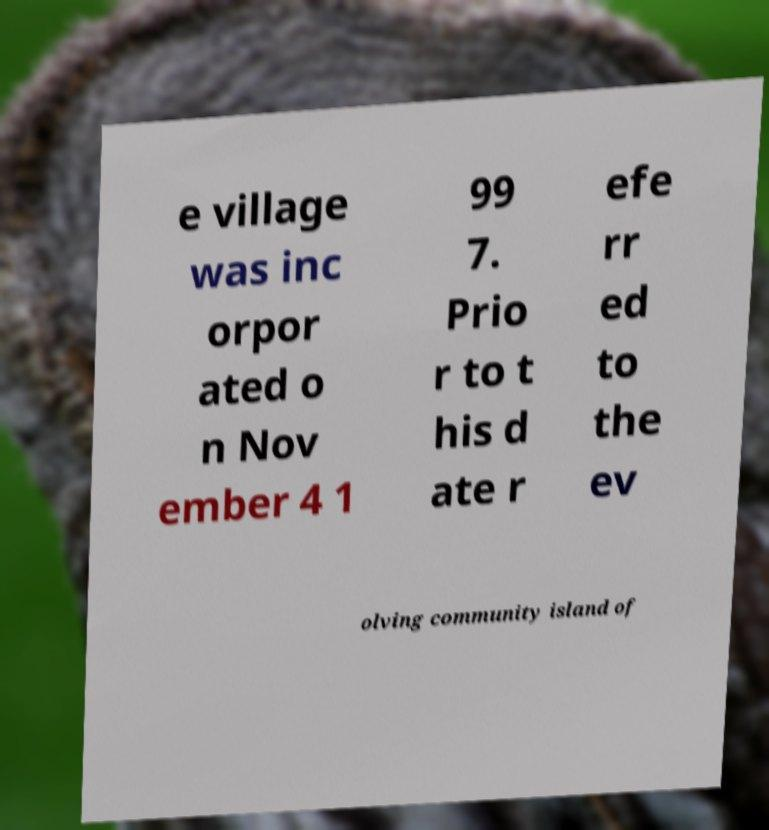Please identify and transcribe the text found in this image. e village was inc orpor ated o n Nov ember 4 1 99 7. Prio r to t his d ate r efe rr ed to the ev olving community island of 